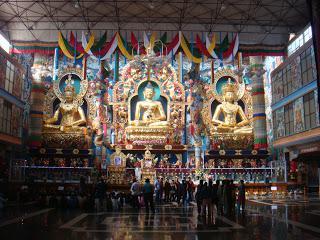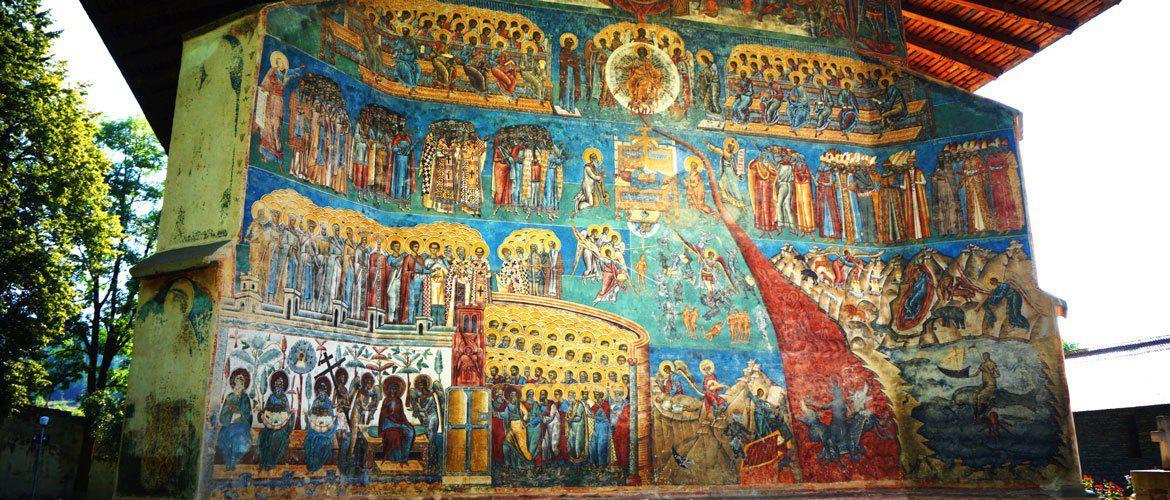The first image is the image on the left, the second image is the image on the right. Examine the images to the left and right. Is the description "There are three religious statues in the left image." accurate? Answer yes or no. Yes. The first image is the image on the left, the second image is the image on the right. Assess this claim about the two images: "The left image features three gold figures in lotus positions side-by-side in a row, with the figures on the ends wearing crowns.". Correct or not? Answer yes or no. Yes. 